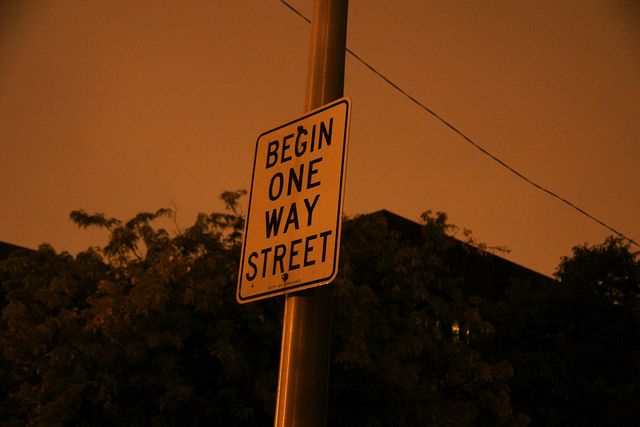<image>Is the name of this street one used by several entities? I am not sure if the name of this street is used by several entities. It's possible that there is no street name. Is the name of this street one used by several entities? I don't know if the name of this street is used by several entities. It can be both yes or no. 